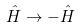Convert formula to latex. <formula><loc_0><loc_0><loc_500><loc_500>\hat { H } \rightarrow - \hat { H }</formula> 